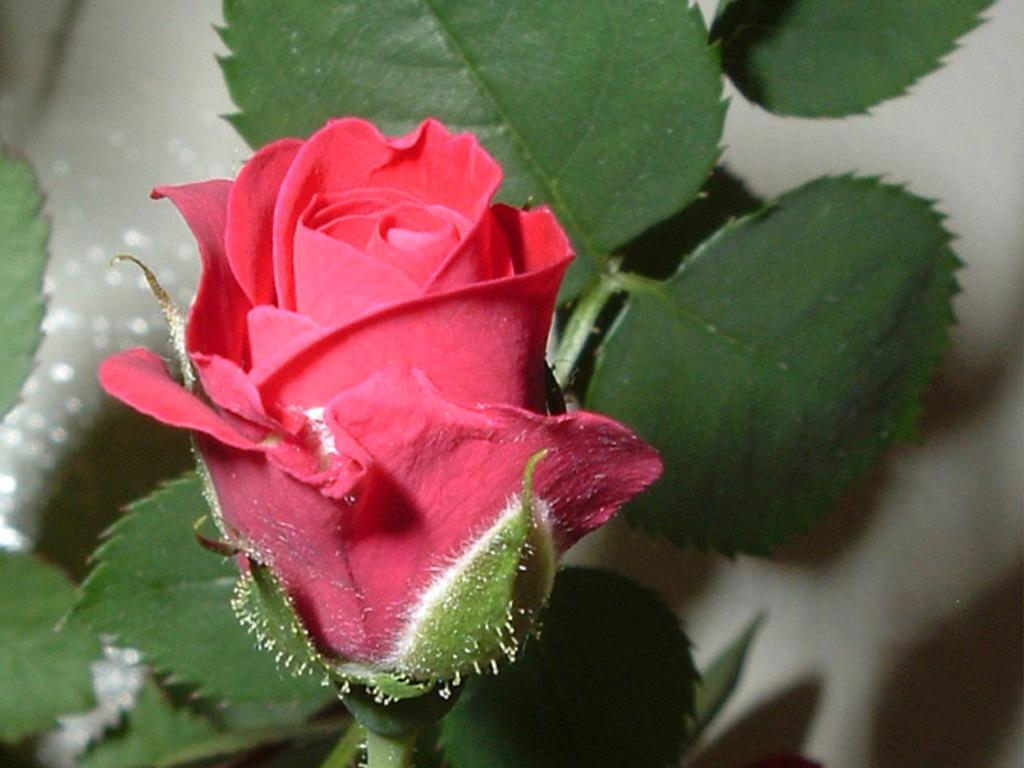What is the main subject of the image? There is a rose flower in the center of the image. Can you describe the background of the image? There are leaves visible in the background of the image. What letters are being written by the partner in the image? There is no partner present in the image, and no letters are being written. 